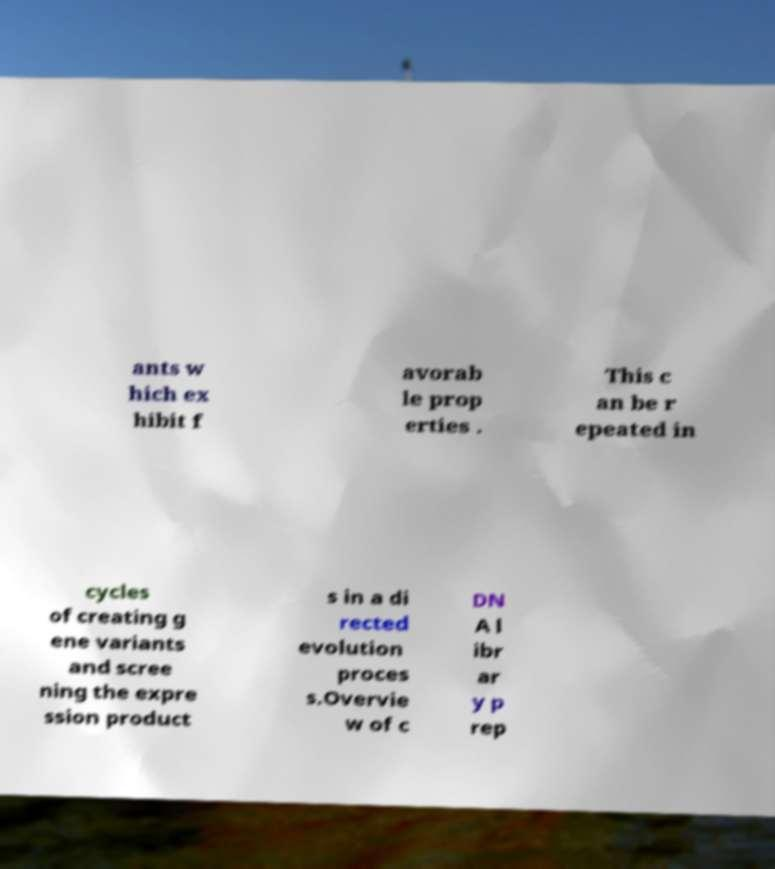Can you read and provide the text displayed in the image?This photo seems to have some interesting text. Can you extract and type it out for me? ants w hich ex hibit f avorab le prop erties . This c an be r epeated in cycles of creating g ene variants and scree ning the expre ssion product s in a di rected evolution proces s.Overvie w of c DN A l ibr ar y p rep 